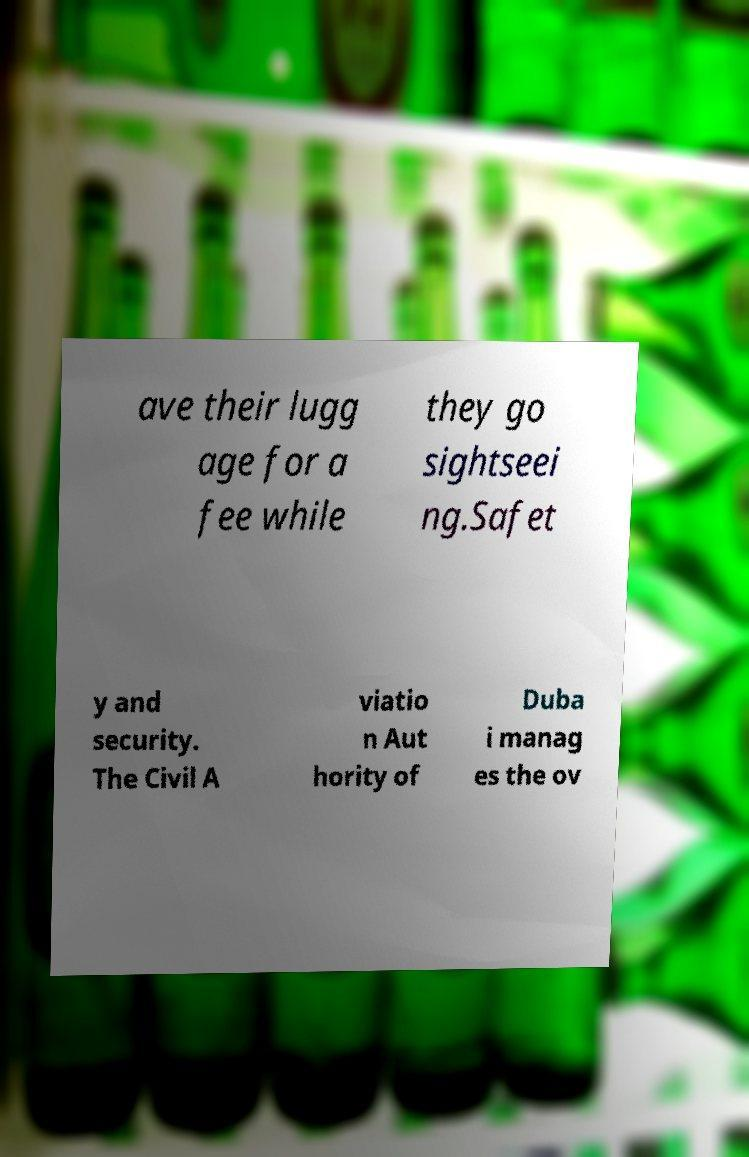Could you assist in decoding the text presented in this image and type it out clearly? ave their lugg age for a fee while they go sightseei ng.Safet y and security. The Civil A viatio n Aut hority of Duba i manag es the ov 